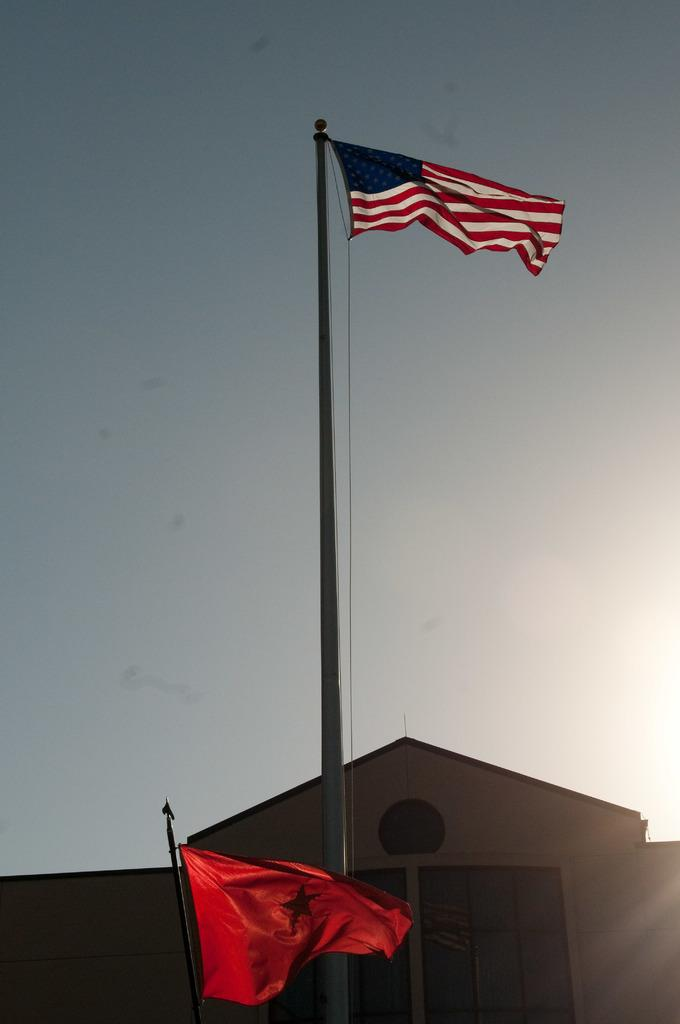What type of structure is present in the image? There is a building in the image. What other objects can be seen in the image? There are flags with poles in the image. What can be seen in the background of the image? The sky is visible in the background of the image. What type of knowledge is being shared by the elbow in the image? There is no elbow present in the image, and therefore no knowledge can be shared by it. 